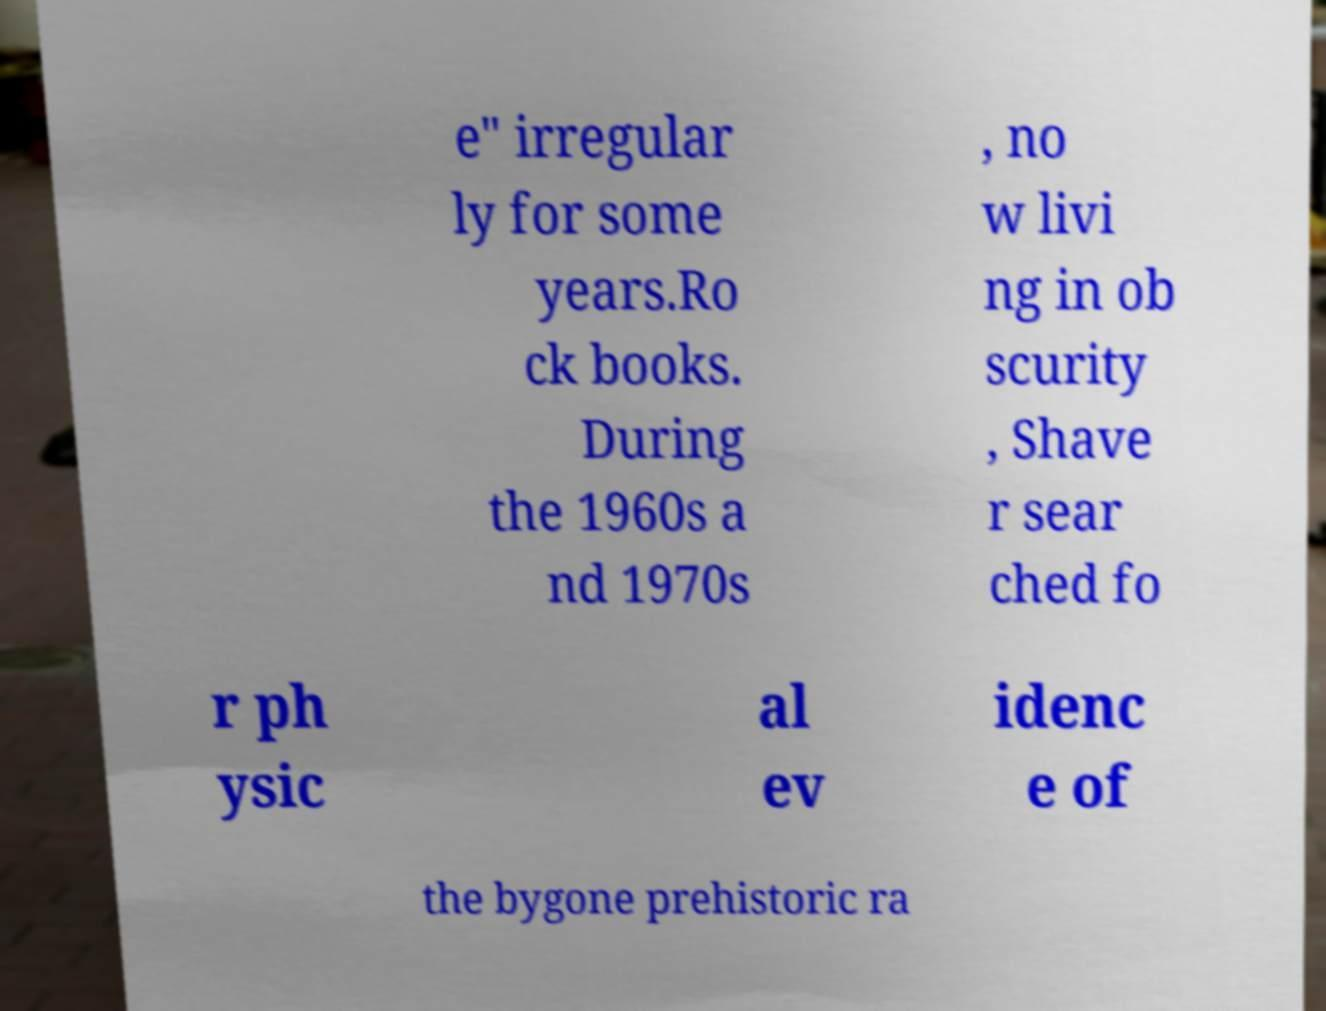Please identify and transcribe the text found in this image. e" irregular ly for some years.Ro ck books. During the 1960s a nd 1970s , no w livi ng in ob scurity , Shave r sear ched fo r ph ysic al ev idenc e of the bygone prehistoric ra 